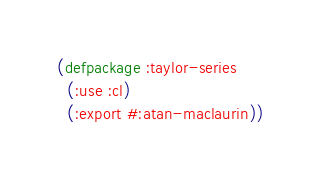Convert code to text. <code><loc_0><loc_0><loc_500><loc_500><_Lisp_>(defpackage :taylor-series
  (:use :cl)
  (:export #:atan-maclaurin))
</code> 